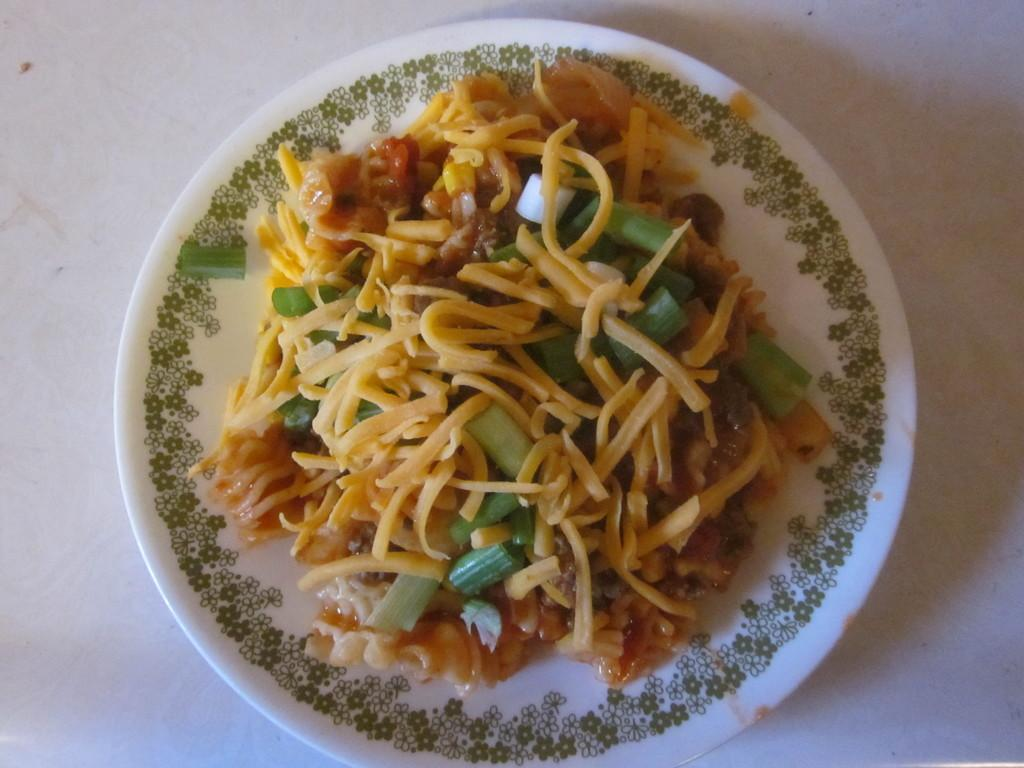What is on the plate in the image? There is a food item on a plate in the image. Can you describe the design on the plate? The plate has a design. What color is the surface the plate is on? The plate is on a white color surface. Is there a receipt for the food item on the plate in the image? There is no information about a receipt in the image; it only shows a food item on a plate with a design on a white color surface. 